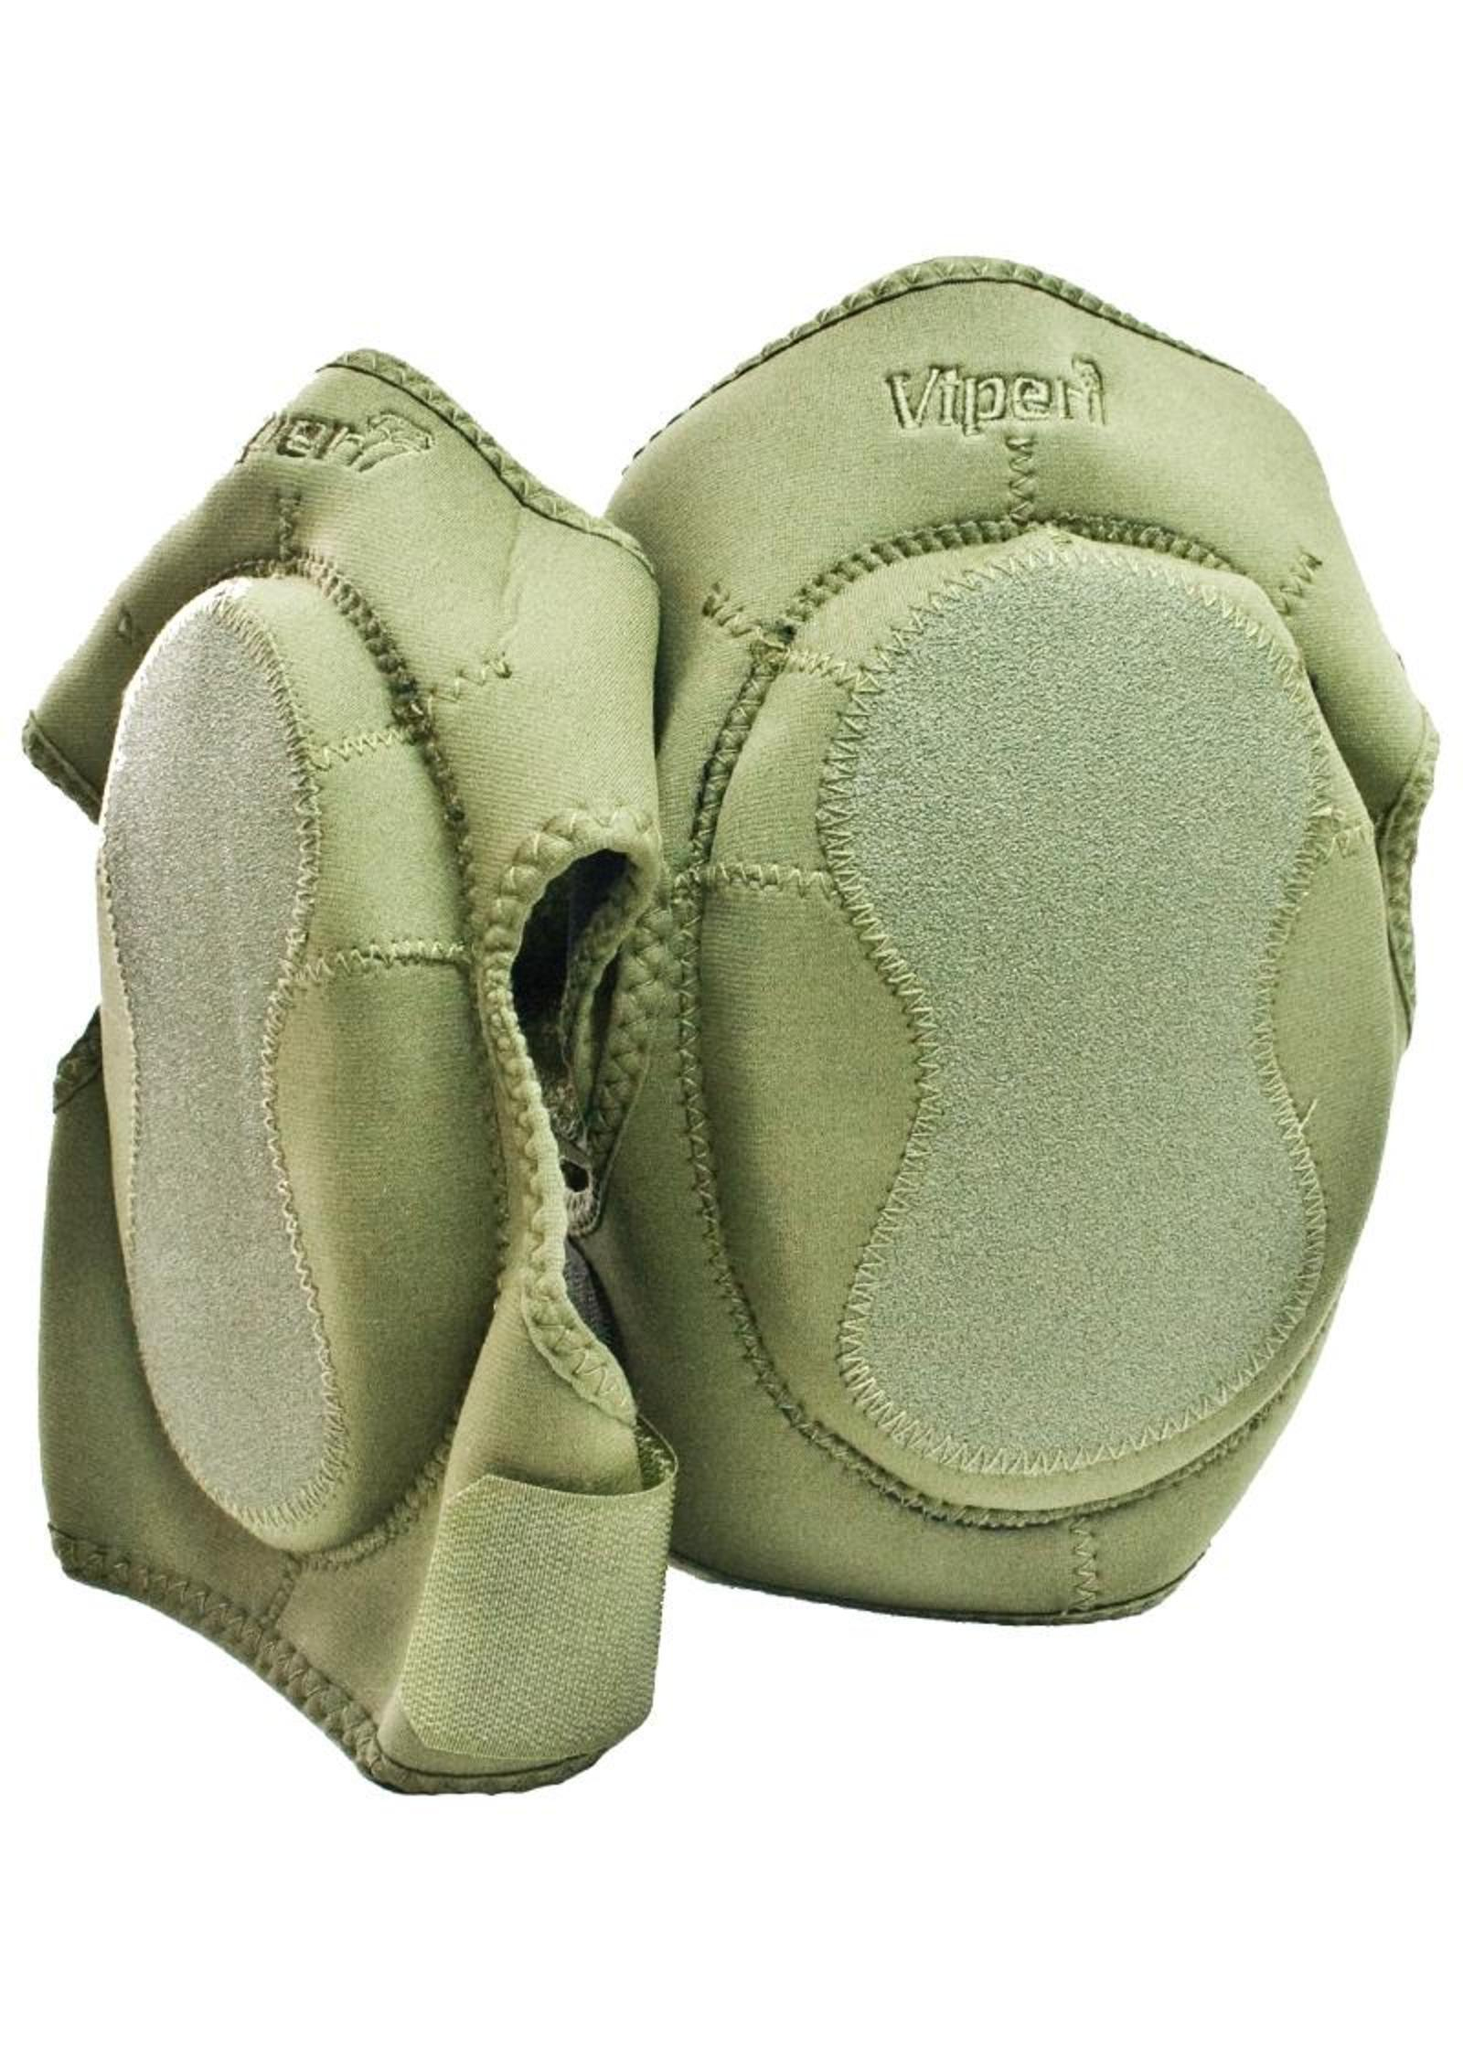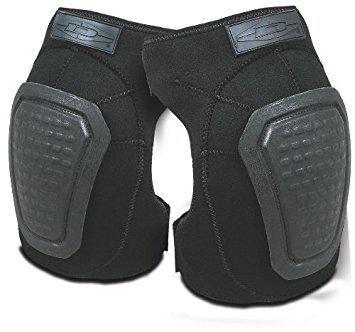The first image is the image on the left, the second image is the image on the right. Analyze the images presented: Is the assertion "At least one image shows a pair of kneepads with a camo pattern." valid? Answer yes or no. No. The first image is the image on the left, the second image is the image on the right. Given the left and right images, does the statement "There are camp patterned knee pads" hold true? Answer yes or no. No. 